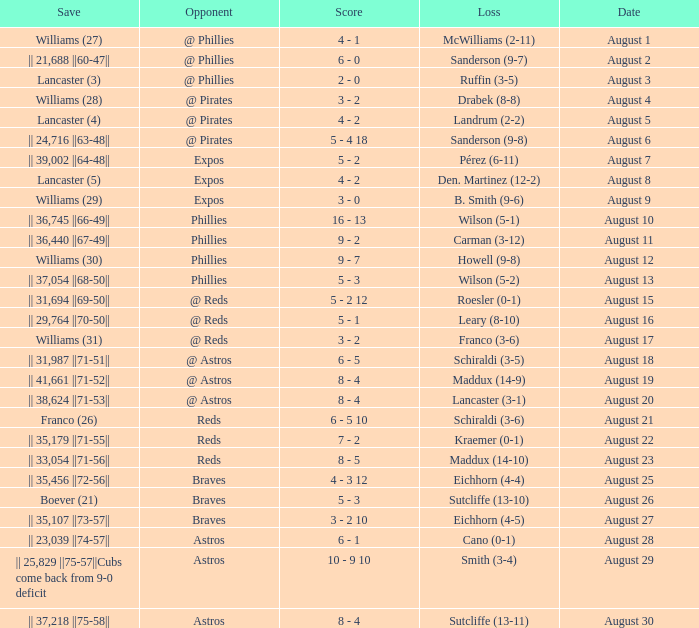Name the date with loss of carman (3-12) August 11. 